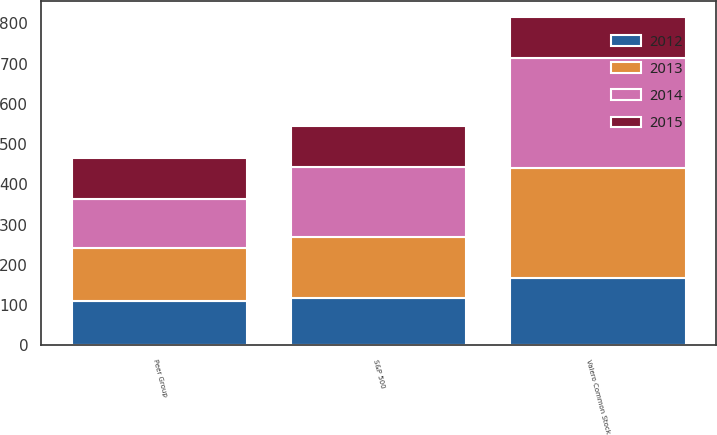Convert chart to OTSL. <chart><loc_0><loc_0><loc_500><loc_500><stacked_bar_chart><ecel><fcel>Valero Common Stock<fcel>S&P 500<fcel>Peer Group<nl><fcel>2015<fcel>100<fcel>100<fcel>100<nl><fcel>2012<fcel>166.17<fcel>116<fcel>109.23<nl><fcel>2013<fcel>274.19<fcel>153.58<fcel>132.93<nl><fcel>2014<fcel>274.85<fcel>174.6<fcel>122.45<nl></chart> 